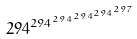Convert formula to latex. <formula><loc_0><loc_0><loc_500><loc_500>2 9 4 ^ { 2 9 4 ^ { 2 9 4 ^ { 2 9 4 ^ { 2 9 4 ^ { 2 9 7 } } } } }</formula> 